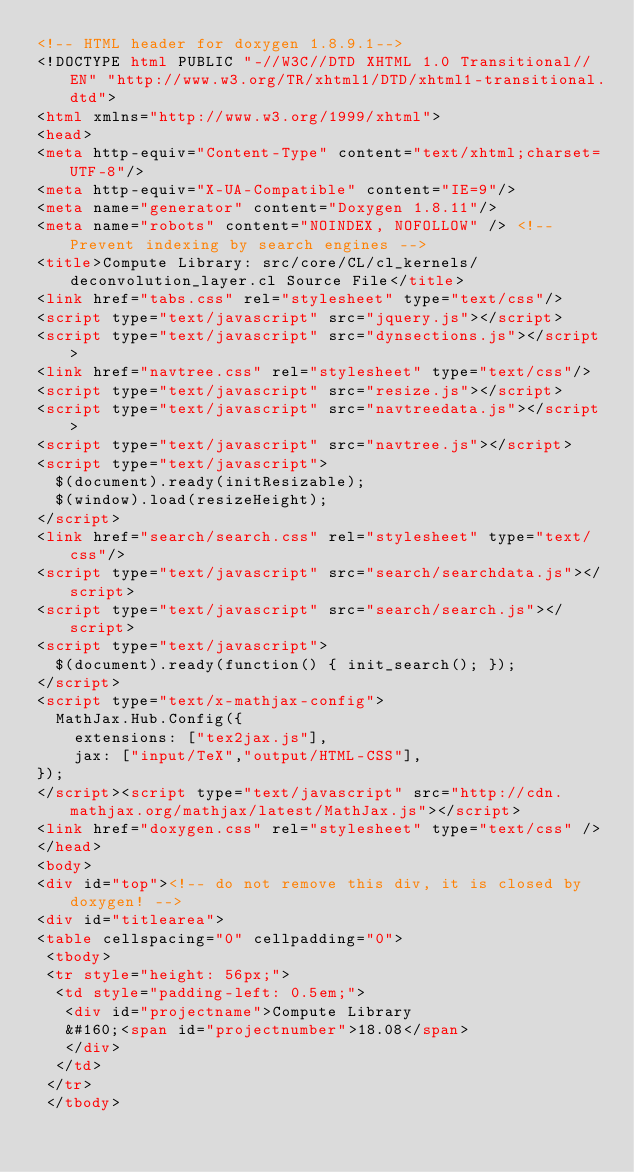Convert code to text. <code><loc_0><loc_0><loc_500><loc_500><_HTML_><!-- HTML header for doxygen 1.8.9.1-->
<!DOCTYPE html PUBLIC "-//W3C//DTD XHTML 1.0 Transitional//EN" "http://www.w3.org/TR/xhtml1/DTD/xhtml1-transitional.dtd">
<html xmlns="http://www.w3.org/1999/xhtml">
<head>
<meta http-equiv="Content-Type" content="text/xhtml;charset=UTF-8"/>
<meta http-equiv="X-UA-Compatible" content="IE=9"/>
<meta name="generator" content="Doxygen 1.8.11"/>
<meta name="robots" content="NOINDEX, NOFOLLOW" /> <!-- Prevent indexing by search engines -->
<title>Compute Library: src/core/CL/cl_kernels/deconvolution_layer.cl Source File</title>
<link href="tabs.css" rel="stylesheet" type="text/css"/>
<script type="text/javascript" src="jquery.js"></script>
<script type="text/javascript" src="dynsections.js"></script>
<link href="navtree.css" rel="stylesheet" type="text/css"/>
<script type="text/javascript" src="resize.js"></script>
<script type="text/javascript" src="navtreedata.js"></script>
<script type="text/javascript" src="navtree.js"></script>
<script type="text/javascript">
  $(document).ready(initResizable);
  $(window).load(resizeHeight);
</script>
<link href="search/search.css" rel="stylesheet" type="text/css"/>
<script type="text/javascript" src="search/searchdata.js"></script>
<script type="text/javascript" src="search/search.js"></script>
<script type="text/javascript">
  $(document).ready(function() { init_search(); });
</script>
<script type="text/x-mathjax-config">
  MathJax.Hub.Config({
    extensions: ["tex2jax.js"],
    jax: ["input/TeX","output/HTML-CSS"],
});
</script><script type="text/javascript" src="http://cdn.mathjax.org/mathjax/latest/MathJax.js"></script>
<link href="doxygen.css" rel="stylesheet" type="text/css" />
</head>
<body>
<div id="top"><!-- do not remove this div, it is closed by doxygen! -->
<div id="titlearea">
<table cellspacing="0" cellpadding="0">
 <tbody>
 <tr style="height: 56px;">
  <td style="padding-left: 0.5em;">
   <div id="projectname">Compute Library
   &#160;<span id="projectnumber">18.08</span>
   </div>
  </td>
 </tr>
 </tbody></code> 